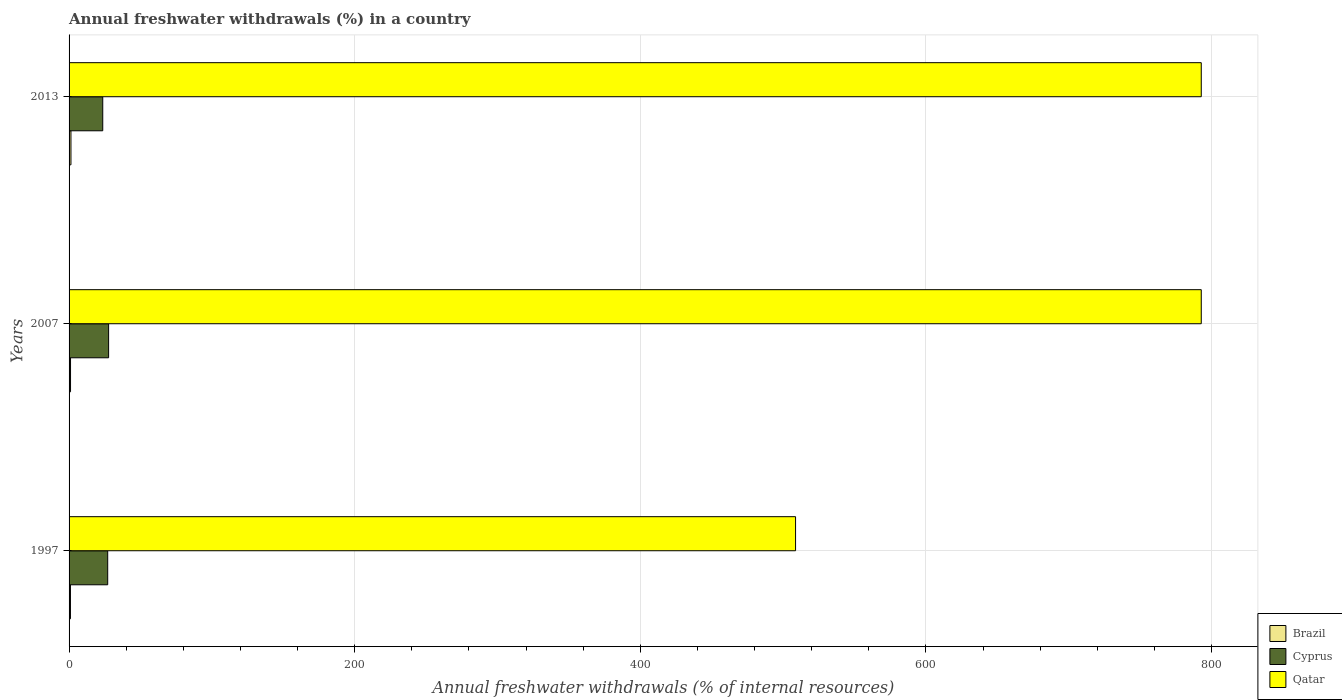How many groups of bars are there?
Make the answer very short. 3. Are the number of bars per tick equal to the number of legend labels?
Offer a very short reply. Yes. Are the number of bars on each tick of the Y-axis equal?
Give a very brief answer. Yes. How many bars are there on the 2nd tick from the top?
Provide a succinct answer. 3. What is the percentage of annual freshwater withdrawals in Brazil in 1997?
Make the answer very short. 0.97. Across all years, what is the maximum percentage of annual freshwater withdrawals in Cyprus?
Give a very brief answer. 27.69. Across all years, what is the minimum percentage of annual freshwater withdrawals in Qatar?
Offer a terse response. 508.75. In which year was the percentage of annual freshwater withdrawals in Qatar maximum?
Give a very brief answer. 2007. In which year was the percentage of annual freshwater withdrawals in Brazil minimum?
Ensure brevity in your answer.  1997. What is the total percentage of annual freshwater withdrawals in Qatar in the graph?
Keep it short and to the point. 2094.46. What is the difference between the percentage of annual freshwater withdrawals in Qatar in 1997 and that in 2013?
Offer a terse response. -284.11. What is the difference between the percentage of annual freshwater withdrawals in Qatar in 1997 and the percentage of annual freshwater withdrawals in Brazil in 2007?
Provide a succinct answer. 507.72. What is the average percentage of annual freshwater withdrawals in Brazil per year?
Offer a very short reply. 1.11. In the year 1997, what is the difference between the percentage of annual freshwater withdrawals in Brazil and percentage of annual freshwater withdrawals in Cyprus?
Give a very brief answer. -26.08. What is the ratio of the percentage of annual freshwater withdrawals in Cyprus in 2007 to that in 2013?
Offer a terse response. 1.17. Is the percentage of annual freshwater withdrawals in Cyprus in 1997 less than that in 2013?
Ensure brevity in your answer.  No. Is the difference between the percentage of annual freshwater withdrawals in Brazil in 2007 and 2013 greater than the difference between the percentage of annual freshwater withdrawals in Cyprus in 2007 and 2013?
Provide a short and direct response. No. What is the difference between the highest and the second highest percentage of annual freshwater withdrawals in Brazil?
Offer a terse response. 0.3. What is the difference between the highest and the lowest percentage of annual freshwater withdrawals in Cyprus?
Your response must be concise. 4.1. In how many years, is the percentage of annual freshwater withdrawals in Qatar greater than the average percentage of annual freshwater withdrawals in Qatar taken over all years?
Your response must be concise. 2. Is the sum of the percentage of annual freshwater withdrawals in Qatar in 1997 and 2007 greater than the maximum percentage of annual freshwater withdrawals in Cyprus across all years?
Your response must be concise. Yes. What does the 2nd bar from the bottom in 2013 represents?
Your answer should be compact. Cyprus. Is it the case that in every year, the sum of the percentage of annual freshwater withdrawals in Cyprus and percentage of annual freshwater withdrawals in Qatar is greater than the percentage of annual freshwater withdrawals in Brazil?
Offer a very short reply. Yes. How many bars are there?
Offer a terse response. 9. What is the difference between two consecutive major ticks on the X-axis?
Give a very brief answer. 200. How are the legend labels stacked?
Ensure brevity in your answer.  Vertical. What is the title of the graph?
Offer a terse response. Annual freshwater withdrawals (%) in a country. Does "Peru" appear as one of the legend labels in the graph?
Your answer should be very brief. No. What is the label or title of the X-axis?
Keep it short and to the point. Annual freshwater withdrawals (% of internal resources). What is the Annual freshwater withdrawals (% of internal resources) in Brazil in 1997?
Your response must be concise. 0.97. What is the Annual freshwater withdrawals (% of internal resources) of Cyprus in 1997?
Provide a short and direct response. 27.05. What is the Annual freshwater withdrawals (% of internal resources) in Qatar in 1997?
Your answer should be compact. 508.75. What is the Annual freshwater withdrawals (% of internal resources) in Brazil in 2007?
Keep it short and to the point. 1.03. What is the Annual freshwater withdrawals (% of internal resources) of Cyprus in 2007?
Make the answer very short. 27.69. What is the Annual freshwater withdrawals (% of internal resources) in Qatar in 2007?
Offer a terse response. 792.86. What is the Annual freshwater withdrawals (% of internal resources) of Brazil in 2013?
Provide a short and direct response. 1.32. What is the Annual freshwater withdrawals (% of internal resources) in Cyprus in 2013?
Provide a short and direct response. 23.59. What is the Annual freshwater withdrawals (% of internal resources) of Qatar in 2013?
Offer a terse response. 792.86. Across all years, what is the maximum Annual freshwater withdrawals (% of internal resources) in Brazil?
Give a very brief answer. 1.32. Across all years, what is the maximum Annual freshwater withdrawals (% of internal resources) in Cyprus?
Provide a short and direct response. 27.69. Across all years, what is the maximum Annual freshwater withdrawals (% of internal resources) of Qatar?
Provide a succinct answer. 792.86. Across all years, what is the minimum Annual freshwater withdrawals (% of internal resources) of Brazil?
Your answer should be compact. 0.97. Across all years, what is the minimum Annual freshwater withdrawals (% of internal resources) in Cyprus?
Your answer should be very brief. 23.59. Across all years, what is the minimum Annual freshwater withdrawals (% of internal resources) of Qatar?
Keep it short and to the point. 508.75. What is the total Annual freshwater withdrawals (% of internal resources) of Brazil in the graph?
Offer a very short reply. 3.32. What is the total Annual freshwater withdrawals (% of internal resources) in Cyprus in the graph?
Give a very brief answer. 78.33. What is the total Annual freshwater withdrawals (% of internal resources) of Qatar in the graph?
Provide a short and direct response. 2094.46. What is the difference between the Annual freshwater withdrawals (% of internal resources) of Brazil in 1997 and that in 2007?
Provide a short and direct response. -0.06. What is the difference between the Annual freshwater withdrawals (% of internal resources) of Cyprus in 1997 and that in 2007?
Keep it short and to the point. -0.64. What is the difference between the Annual freshwater withdrawals (% of internal resources) of Qatar in 1997 and that in 2007?
Keep it short and to the point. -284.11. What is the difference between the Annual freshwater withdrawals (% of internal resources) in Brazil in 1997 and that in 2013?
Your answer should be compact. -0.35. What is the difference between the Annual freshwater withdrawals (% of internal resources) in Cyprus in 1997 and that in 2013?
Ensure brevity in your answer.  3.46. What is the difference between the Annual freshwater withdrawals (% of internal resources) of Qatar in 1997 and that in 2013?
Give a very brief answer. -284.11. What is the difference between the Annual freshwater withdrawals (% of internal resources) in Brazil in 2007 and that in 2013?
Provide a short and direct response. -0.3. What is the difference between the Annual freshwater withdrawals (% of internal resources) of Cyprus in 2007 and that in 2013?
Keep it short and to the point. 4.1. What is the difference between the Annual freshwater withdrawals (% of internal resources) in Brazil in 1997 and the Annual freshwater withdrawals (% of internal resources) in Cyprus in 2007?
Offer a very short reply. -26.72. What is the difference between the Annual freshwater withdrawals (% of internal resources) in Brazil in 1997 and the Annual freshwater withdrawals (% of internal resources) in Qatar in 2007?
Ensure brevity in your answer.  -791.89. What is the difference between the Annual freshwater withdrawals (% of internal resources) of Cyprus in 1997 and the Annual freshwater withdrawals (% of internal resources) of Qatar in 2007?
Make the answer very short. -765.81. What is the difference between the Annual freshwater withdrawals (% of internal resources) of Brazil in 1997 and the Annual freshwater withdrawals (% of internal resources) of Cyprus in 2013?
Offer a very short reply. -22.62. What is the difference between the Annual freshwater withdrawals (% of internal resources) of Brazil in 1997 and the Annual freshwater withdrawals (% of internal resources) of Qatar in 2013?
Provide a succinct answer. -791.89. What is the difference between the Annual freshwater withdrawals (% of internal resources) of Cyprus in 1997 and the Annual freshwater withdrawals (% of internal resources) of Qatar in 2013?
Your response must be concise. -765.81. What is the difference between the Annual freshwater withdrawals (% of internal resources) in Brazil in 2007 and the Annual freshwater withdrawals (% of internal resources) in Cyprus in 2013?
Ensure brevity in your answer.  -22.56. What is the difference between the Annual freshwater withdrawals (% of internal resources) in Brazil in 2007 and the Annual freshwater withdrawals (% of internal resources) in Qatar in 2013?
Keep it short and to the point. -791.83. What is the difference between the Annual freshwater withdrawals (% of internal resources) in Cyprus in 2007 and the Annual freshwater withdrawals (% of internal resources) in Qatar in 2013?
Your answer should be compact. -765.16. What is the average Annual freshwater withdrawals (% of internal resources) in Brazil per year?
Offer a terse response. 1.11. What is the average Annual freshwater withdrawals (% of internal resources) of Cyprus per year?
Your response must be concise. 26.11. What is the average Annual freshwater withdrawals (% of internal resources) of Qatar per year?
Your answer should be compact. 698.15. In the year 1997, what is the difference between the Annual freshwater withdrawals (% of internal resources) in Brazil and Annual freshwater withdrawals (% of internal resources) in Cyprus?
Keep it short and to the point. -26.08. In the year 1997, what is the difference between the Annual freshwater withdrawals (% of internal resources) of Brazil and Annual freshwater withdrawals (% of internal resources) of Qatar?
Offer a terse response. -507.78. In the year 1997, what is the difference between the Annual freshwater withdrawals (% of internal resources) of Cyprus and Annual freshwater withdrawals (% of internal resources) of Qatar?
Keep it short and to the point. -481.7. In the year 2007, what is the difference between the Annual freshwater withdrawals (% of internal resources) of Brazil and Annual freshwater withdrawals (% of internal resources) of Cyprus?
Keep it short and to the point. -26.67. In the year 2007, what is the difference between the Annual freshwater withdrawals (% of internal resources) in Brazil and Annual freshwater withdrawals (% of internal resources) in Qatar?
Your answer should be very brief. -791.83. In the year 2007, what is the difference between the Annual freshwater withdrawals (% of internal resources) in Cyprus and Annual freshwater withdrawals (% of internal resources) in Qatar?
Offer a very short reply. -765.16. In the year 2013, what is the difference between the Annual freshwater withdrawals (% of internal resources) of Brazil and Annual freshwater withdrawals (% of internal resources) of Cyprus?
Provide a short and direct response. -22.27. In the year 2013, what is the difference between the Annual freshwater withdrawals (% of internal resources) in Brazil and Annual freshwater withdrawals (% of internal resources) in Qatar?
Your answer should be very brief. -791.54. In the year 2013, what is the difference between the Annual freshwater withdrawals (% of internal resources) of Cyprus and Annual freshwater withdrawals (% of internal resources) of Qatar?
Keep it short and to the point. -769.27. What is the ratio of the Annual freshwater withdrawals (% of internal resources) of Brazil in 1997 to that in 2007?
Provide a succinct answer. 0.94. What is the ratio of the Annual freshwater withdrawals (% of internal resources) of Cyprus in 1997 to that in 2007?
Your answer should be compact. 0.98. What is the ratio of the Annual freshwater withdrawals (% of internal resources) in Qatar in 1997 to that in 2007?
Provide a succinct answer. 0.64. What is the ratio of the Annual freshwater withdrawals (% of internal resources) in Brazil in 1997 to that in 2013?
Your answer should be very brief. 0.73. What is the ratio of the Annual freshwater withdrawals (% of internal resources) of Cyprus in 1997 to that in 2013?
Provide a short and direct response. 1.15. What is the ratio of the Annual freshwater withdrawals (% of internal resources) of Qatar in 1997 to that in 2013?
Ensure brevity in your answer.  0.64. What is the ratio of the Annual freshwater withdrawals (% of internal resources) of Brazil in 2007 to that in 2013?
Your answer should be compact. 0.78. What is the ratio of the Annual freshwater withdrawals (% of internal resources) in Cyprus in 2007 to that in 2013?
Provide a short and direct response. 1.17. What is the ratio of the Annual freshwater withdrawals (% of internal resources) in Qatar in 2007 to that in 2013?
Your answer should be very brief. 1. What is the difference between the highest and the second highest Annual freshwater withdrawals (% of internal resources) in Brazil?
Your answer should be compact. 0.3. What is the difference between the highest and the second highest Annual freshwater withdrawals (% of internal resources) in Cyprus?
Provide a succinct answer. 0.64. What is the difference between the highest and the lowest Annual freshwater withdrawals (% of internal resources) in Brazil?
Your answer should be compact. 0.35. What is the difference between the highest and the lowest Annual freshwater withdrawals (% of internal resources) of Cyprus?
Your answer should be compact. 4.1. What is the difference between the highest and the lowest Annual freshwater withdrawals (% of internal resources) of Qatar?
Your response must be concise. 284.11. 